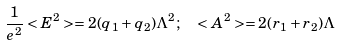<formula> <loc_0><loc_0><loc_500><loc_500>\frac { 1 } { e ^ { 2 } } < E ^ { 2 } > = 2 ( q _ { 1 } + q _ { 2 } ) \Lambda ^ { 2 } ; \ \ < A ^ { 2 } > = 2 ( r _ { 1 } + r _ { 2 } ) \Lambda</formula> 